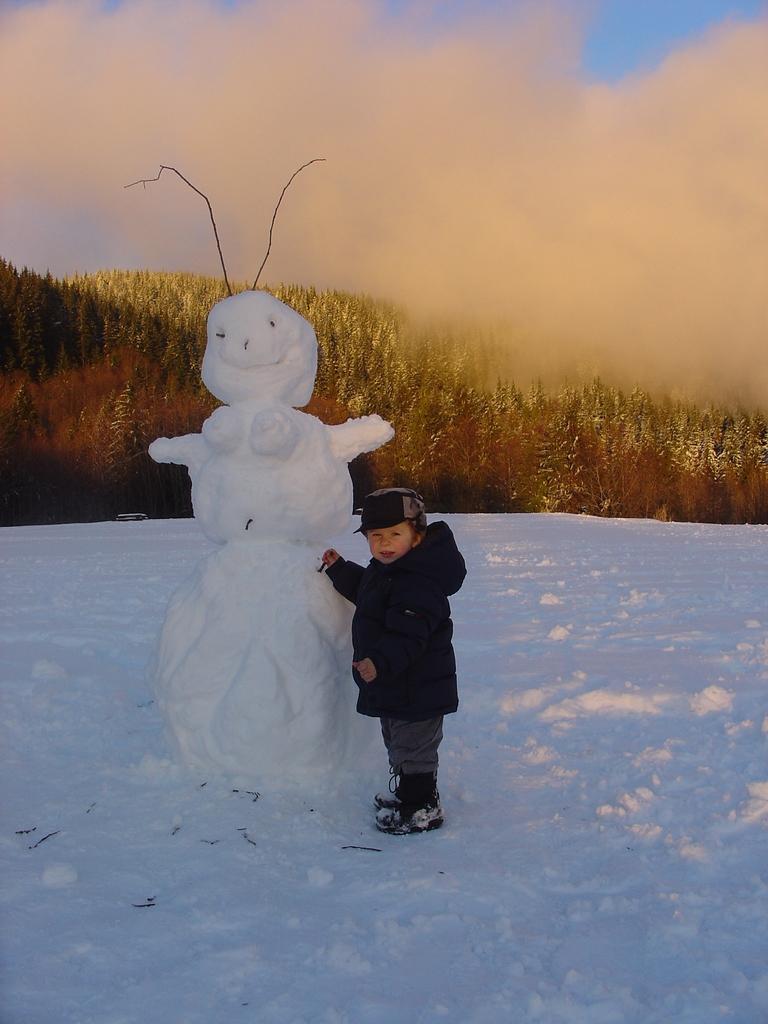Could you give a brief overview of what you see in this image? In this image we can see a boy, beside to him there is a snowman, there are trees, also we can see the sky, and the snow. 